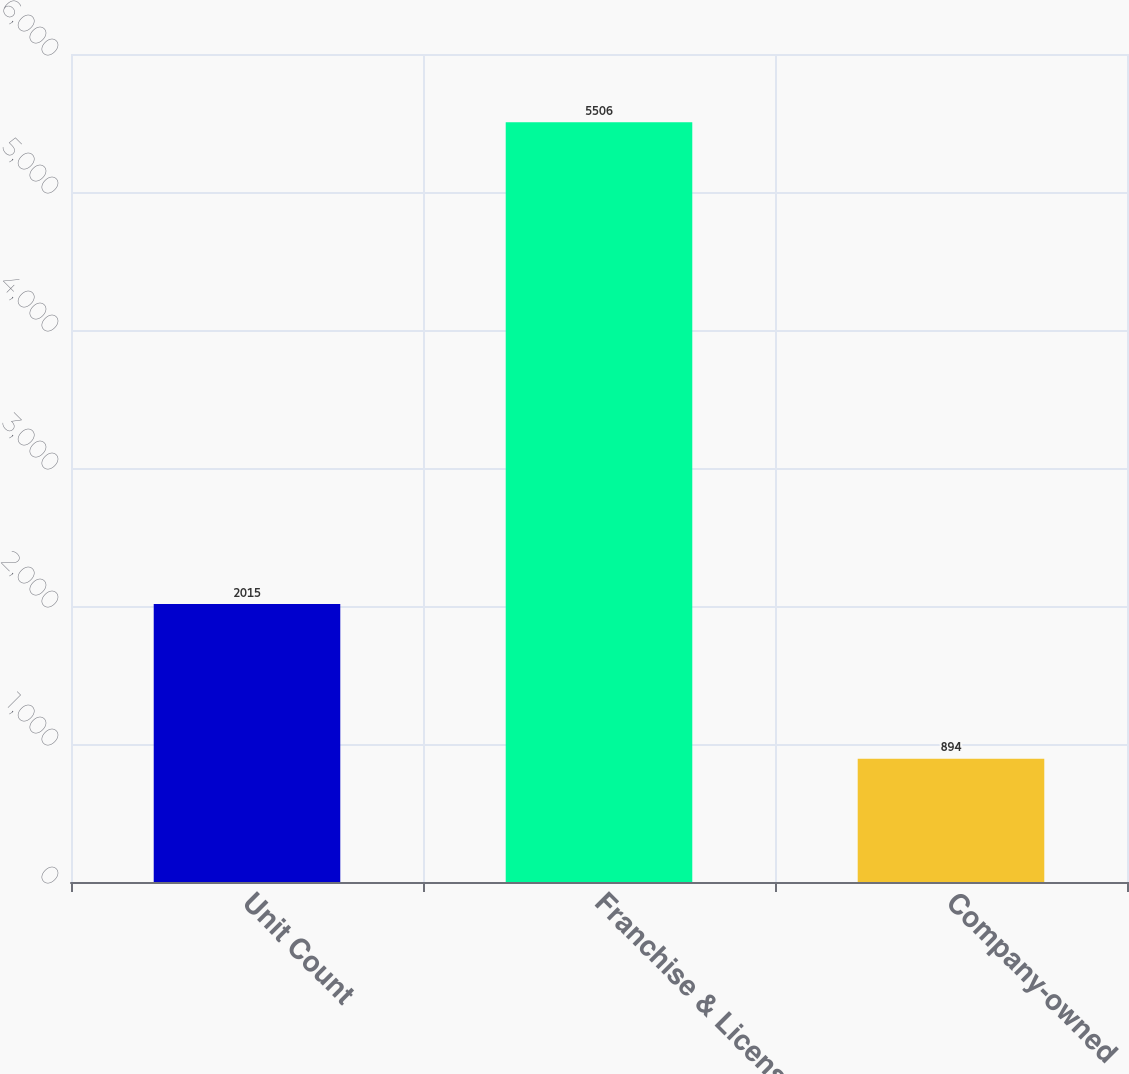<chart> <loc_0><loc_0><loc_500><loc_500><bar_chart><fcel>Unit Count<fcel>Franchise & License<fcel>Company-owned<nl><fcel>2015<fcel>5506<fcel>894<nl></chart> 